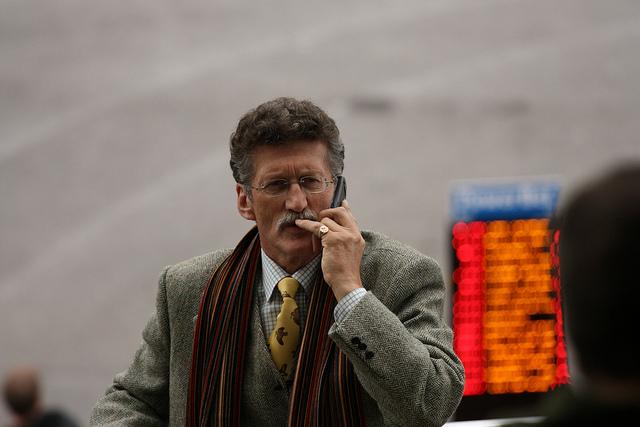What is the man doing with his left hand?
Be succinct. Holding phone. Is there a woman in the photo?
Be succinct. No. What is the man holding in his hand?
Short answer required. Cell phone. What color are the ties?
Give a very brief answer. Yellow. Is the sign beside the man easily readable?
Be succinct. No. Does the man wear glasses?
Give a very brief answer. Yes. What color is the jacket?
Quick response, please. Gray. Are the men eating something?
Keep it brief. No. What do you think this man is thinking?
Quick response, please. What should i say. What color is his tie?
Keep it brief. Yellow. 